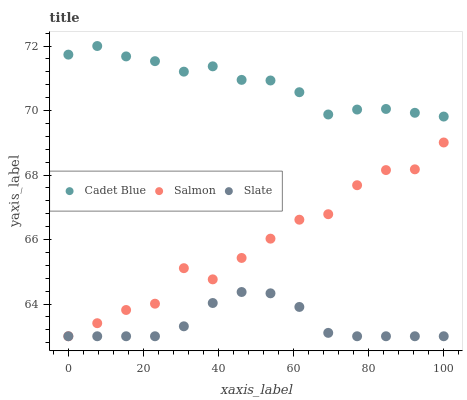Does Slate have the minimum area under the curve?
Answer yes or no. Yes. Does Cadet Blue have the maximum area under the curve?
Answer yes or no. Yes. Does Salmon have the minimum area under the curve?
Answer yes or no. No. Does Salmon have the maximum area under the curve?
Answer yes or no. No. Is Slate the smoothest?
Answer yes or no. Yes. Is Salmon the roughest?
Answer yes or no. Yes. Is Cadet Blue the smoothest?
Answer yes or no. No. Is Cadet Blue the roughest?
Answer yes or no. No. Does Slate have the lowest value?
Answer yes or no. Yes. Does Cadet Blue have the lowest value?
Answer yes or no. No. Does Cadet Blue have the highest value?
Answer yes or no. Yes. Does Salmon have the highest value?
Answer yes or no. No. Is Salmon less than Cadet Blue?
Answer yes or no. Yes. Is Cadet Blue greater than Salmon?
Answer yes or no. Yes. Does Slate intersect Salmon?
Answer yes or no. Yes. Is Slate less than Salmon?
Answer yes or no. No. Is Slate greater than Salmon?
Answer yes or no. No. Does Salmon intersect Cadet Blue?
Answer yes or no. No. 